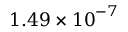Convert formula to latex. <formula><loc_0><loc_0><loc_500><loc_500>1 . 4 9 \times { { 1 0 } ^ { - 7 } }</formula> 